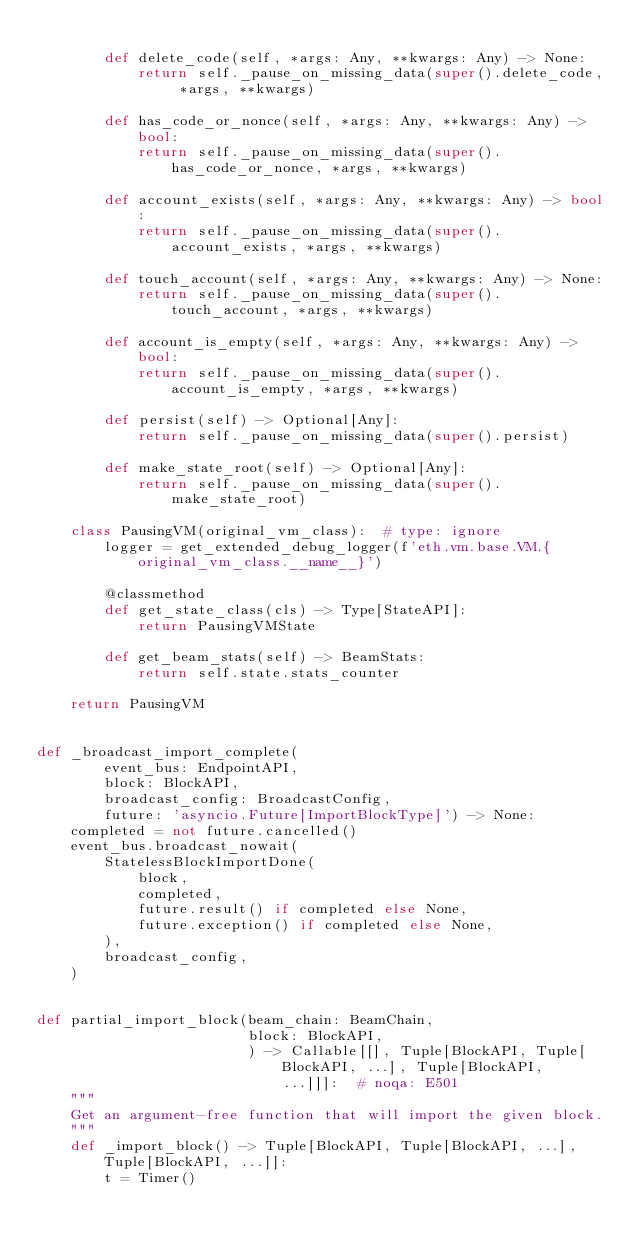<code> <loc_0><loc_0><loc_500><loc_500><_Python_>
        def delete_code(self, *args: Any, **kwargs: Any) -> None:
            return self._pause_on_missing_data(super().delete_code, *args, **kwargs)

        def has_code_or_nonce(self, *args: Any, **kwargs: Any) -> bool:
            return self._pause_on_missing_data(super().has_code_or_nonce, *args, **kwargs)

        def account_exists(self, *args: Any, **kwargs: Any) -> bool:
            return self._pause_on_missing_data(super().account_exists, *args, **kwargs)

        def touch_account(self, *args: Any, **kwargs: Any) -> None:
            return self._pause_on_missing_data(super().touch_account, *args, **kwargs)

        def account_is_empty(self, *args: Any, **kwargs: Any) -> bool:
            return self._pause_on_missing_data(super().account_is_empty, *args, **kwargs)

        def persist(self) -> Optional[Any]:
            return self._pause_on_missing_data(super().persist)

        def make_state_root(self) -> Optional[Any]:
            return self._pause_on_missing_data(super().make_state_root)

    class PausingVM(original_vm_class):  # type: ignore
        logger = get_extended_debug_logger(f'eth.vm.base.VM.{original_vm_class.__name__}')

        @classmethod
        def get_state_class(cls) -> Type[StateAPI]:
            return PausingVMState

        def get_beam_stats(self) -> BeamStats:
            return self.state.stats_counter

    return PausingVM


def _broadcast_import_complete(
        event_bus: EndpointAPI,
        block: BlockAPI,
        broadcast_config: BroadcastConfig,
        future: 'asyncio.Future[ImportBlockType]') -> None:
    completed = not future.cancelled()
    event_bus.broadcast_nowait(
        StatelessBlockImportDone(
            block,
            completed,
            future.result() if completed else None,
            future.exception() if completed else None,
        ),
        broadcast_config,
    )


def partial_import_block(beam_chain: BeamChain,
                         block: BlockAPI,
                         ) -> Callable[[], Tuple[BlockAPI, Tuple[BlockAPI, ...], Tuple[BlockAPI, ...]]]:  # noqa: E501
    """
    Get an argument-free function that will import the given block.
    """
    def _import_block() -> Tuple[BlockAPI, Tuple[BlockAPI, ...], Tuple[BlockAPI, ...]]:
        t = Timer()</code> 